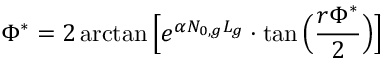<formula> <loc_0><loc_0><loc_500><loc_500>\Phi ^ { * } = 2 \arctan \left [ e ^ { \alpha N _ { 0 , g } L _ { g } } \cdot \tan \left ( \frac { r \Phi ^ { * } } { 2 } \right ) \right ]</formula> 